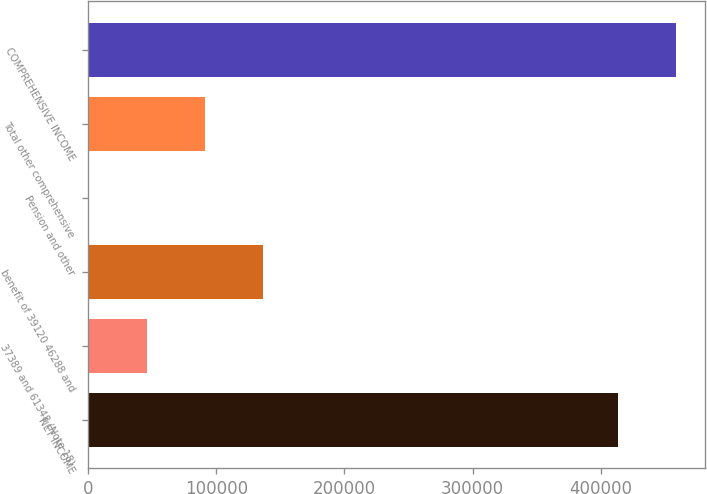Convert chart to OTSL. <chart><loc_0><loc_0><loc_500><loc_500><bar_chart><fcel>NET INCOME<fcel>37389 and 61348 (Note 18)<fcel>benefit of 39120 46288 and<fcel>Pension and other<fcel>Total other comprehensive<fcel>COMPREHENSIVE INCOME<nl><fcel>413164<fcel>46059.8<fcel>136117<fcel>1031<fcel>91088.6<fcel>458193<nl></chart> 